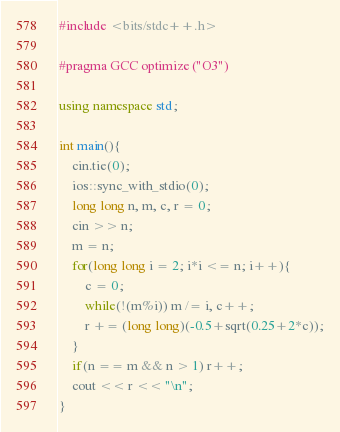<code> <loc_0><loc_0><loc_500><loc_500><_C++_>#include <bits/stdc++.h>

#pragma GCC optimize ("O3")

using namespace std;

int main(){
	cin.tie(0);
	ios::sync_with_stdio(0);
	long long n, m, c, r = 0;
	cin >> n;
	m = n;
	for(long long i = 2; i*i <= n; i++){
		c = 0;
		while(!(m%i)) m /= i, c++;
		r += (long long)(-0.5+sqrt(0.25+2*c));
	}
	if(n == m && n > 1) r++;
	cout << r << "\n";
}
</code> 